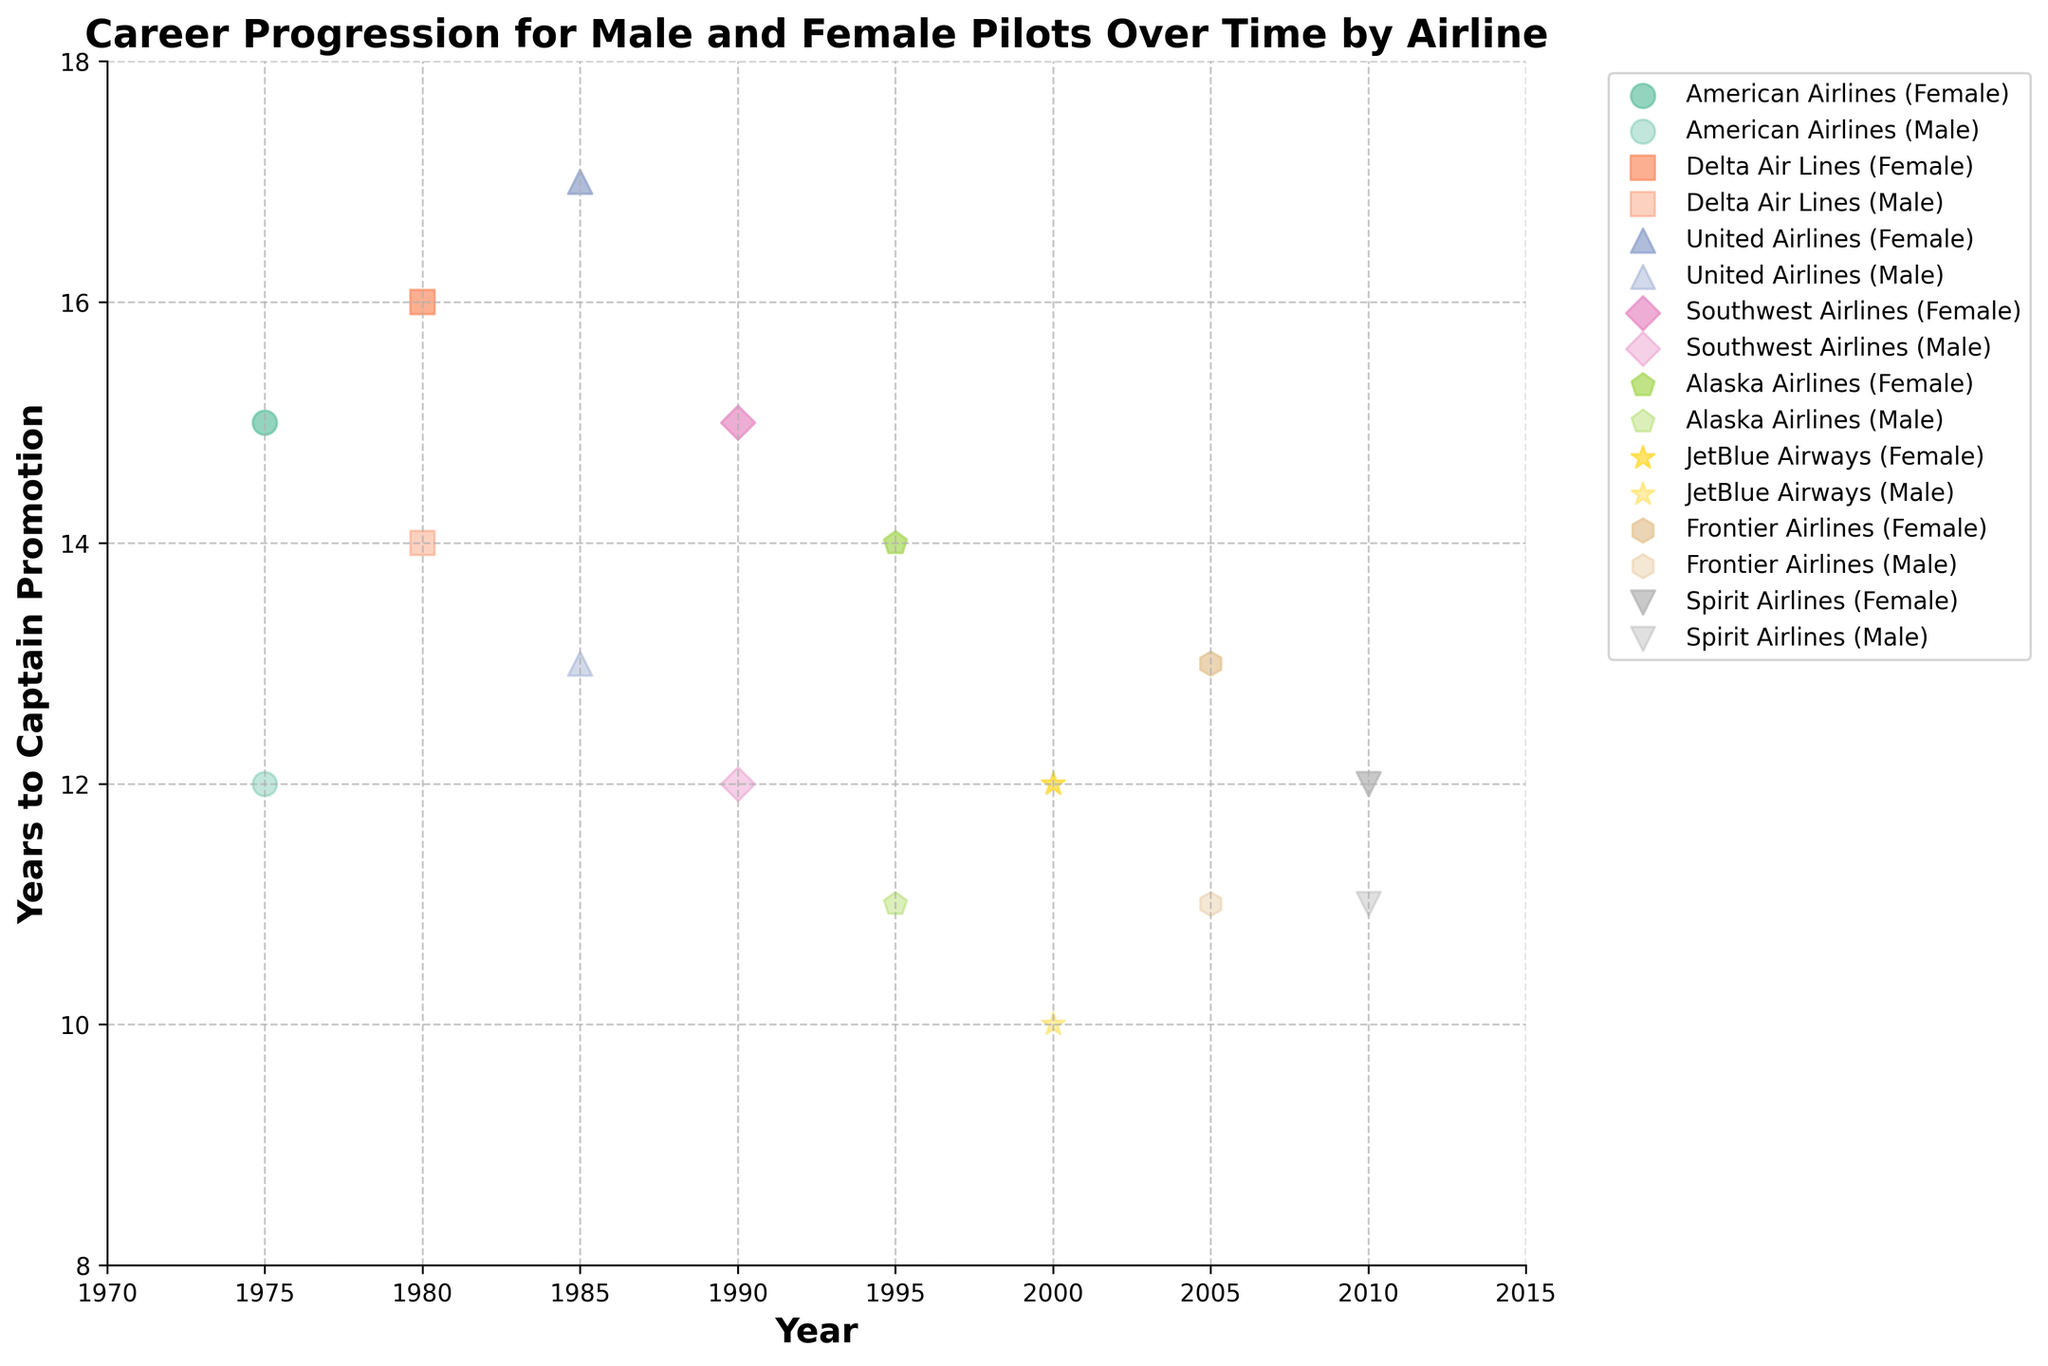How many airlines are represented in the scatter plot? There are different markers and colors for each airline in the plot. You can count the number of unique markers or colors used to represent each airline.
Answer: 8 What does the y-axis represent in the scatter plot? The y-axis label indicates "Years to Captain Promotion," which means it shows the number of years it took for pilots to be promoted to Captain.
Answer: Years to Captain Promotion Which airline has the shortest average promotion time to Captain for male pilots? By looking at the y-axis values for male pilots across all airlines, you can identify which one has the lowest average promotion times. In this plot, Alaska Airlines for male pilots shows a promotion time of 11 years.
Answer: Alaska Airlines Which year has the longest promotion time to Captain for female pilots? Examine the y-axis values for the dots representing female pilots. The year 1985 for United Airlines shows a promotion time of 17 years for female pilots.
Answer: 1985 Are there any airlines where female pilots have a shorter promotion time to Captain compared to male pilots? Compare the y-axis values for each airline, considering both male and female data points. JetBlue Airways in the year 2000 shows female pilots having a promotion time of 12 years, while male pilots in the same year have a promotion time of 10 years, making it inapplicable here.
Answer: No What is the range of years to promotion to Captain for male pilots in this plot? Identify the minimum and maximum values on the y-axis for all male pilot data points. The minimum is 10 years (JetBlue Airways, 2000) and the maximum is 14 years (Delta Air Lines, 1980). So, the range is 14 - 10 = 4 years.
Answer: 4 years Which airline shows the most significant gender disparity in promotion time to Captain? Compare the y-axis values within each airline to see the differences between male and female pilots. United Airlines in 1985 has male promotion times at 13 years and female promotion times at 17 years, resulting in a disparity of 4 years.
Answer: United Airlines How does the trend in promotion time to Captain for female pilots compare over the years? Look at the scatter plot's pattern for female pilots over the years. The trend shows a typically consistent promotion time to Captain, generally in the range of 12 to 17 years without significant fluctuations.
Answer: Consistent In which year did female pilots from Frontier Airlines achieve Captain promotions, and how long did it take? Check the data points labeled Frontier Airlines for female pilots. In 2005, female pilots achieved Captain positions in 13 years.
Answer: 2005, 13 years 